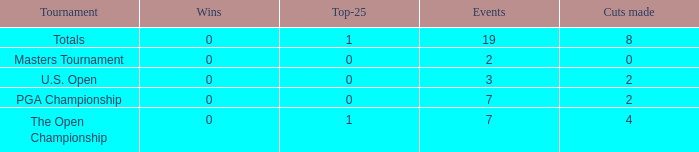What is the lowest Top-25 with Wins less than 0? None. 